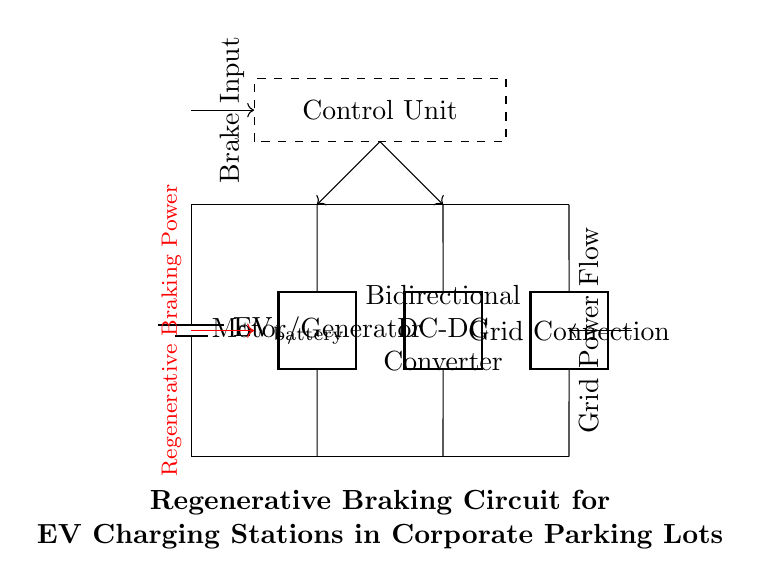What is the primary function of the motor/generator in this circuit? The motor/generator is responsible for converting mechanical energy into electrical energy during regenerative braking, allowing the vehicle to recover energy while slowing down.
Answer: Convert energy What component connects the EV battery to the regenerative braking system? The connection between the EV battery and the motor/generator is direct, facilitating energy transfer during braking.
Answer: The battery How does the grid connection interact with the circuit? The grid connection allows for additional power supply when needed and can also facilitate power return to the grid during charging.
Answer: Power supply What is the role of the control unit in this circuit? The control unit manages the operation of the motor/generator and the DC-DC converter, ensuring efficient energy transfer during regenerative braking and charging.
Answer: Management What type of power flow is indicated by the red arrow? The red arrow indicates the flow of energy being recovered from the vehicle's braking process back into the battery.
Answer: Regenerative braking power What does the dashed rectangle represent in the circuit? The dashed rectangle signifies the area where the control unit operates, implying that it encompasses several control functions for the system.
Answer: Control unit area 